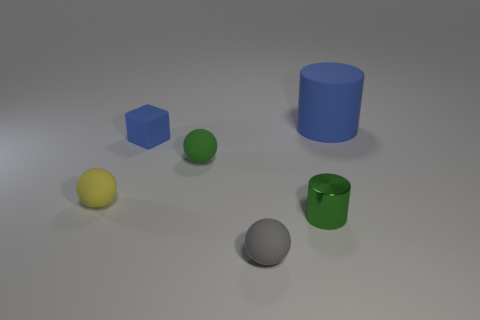Do the objects share any similarities in texture or material? The objects seem to have matte textures with no discernible patterns or roughness, implying they might be made from materials like matte plastic, clay, or painted wood, common in models or educational tools. 